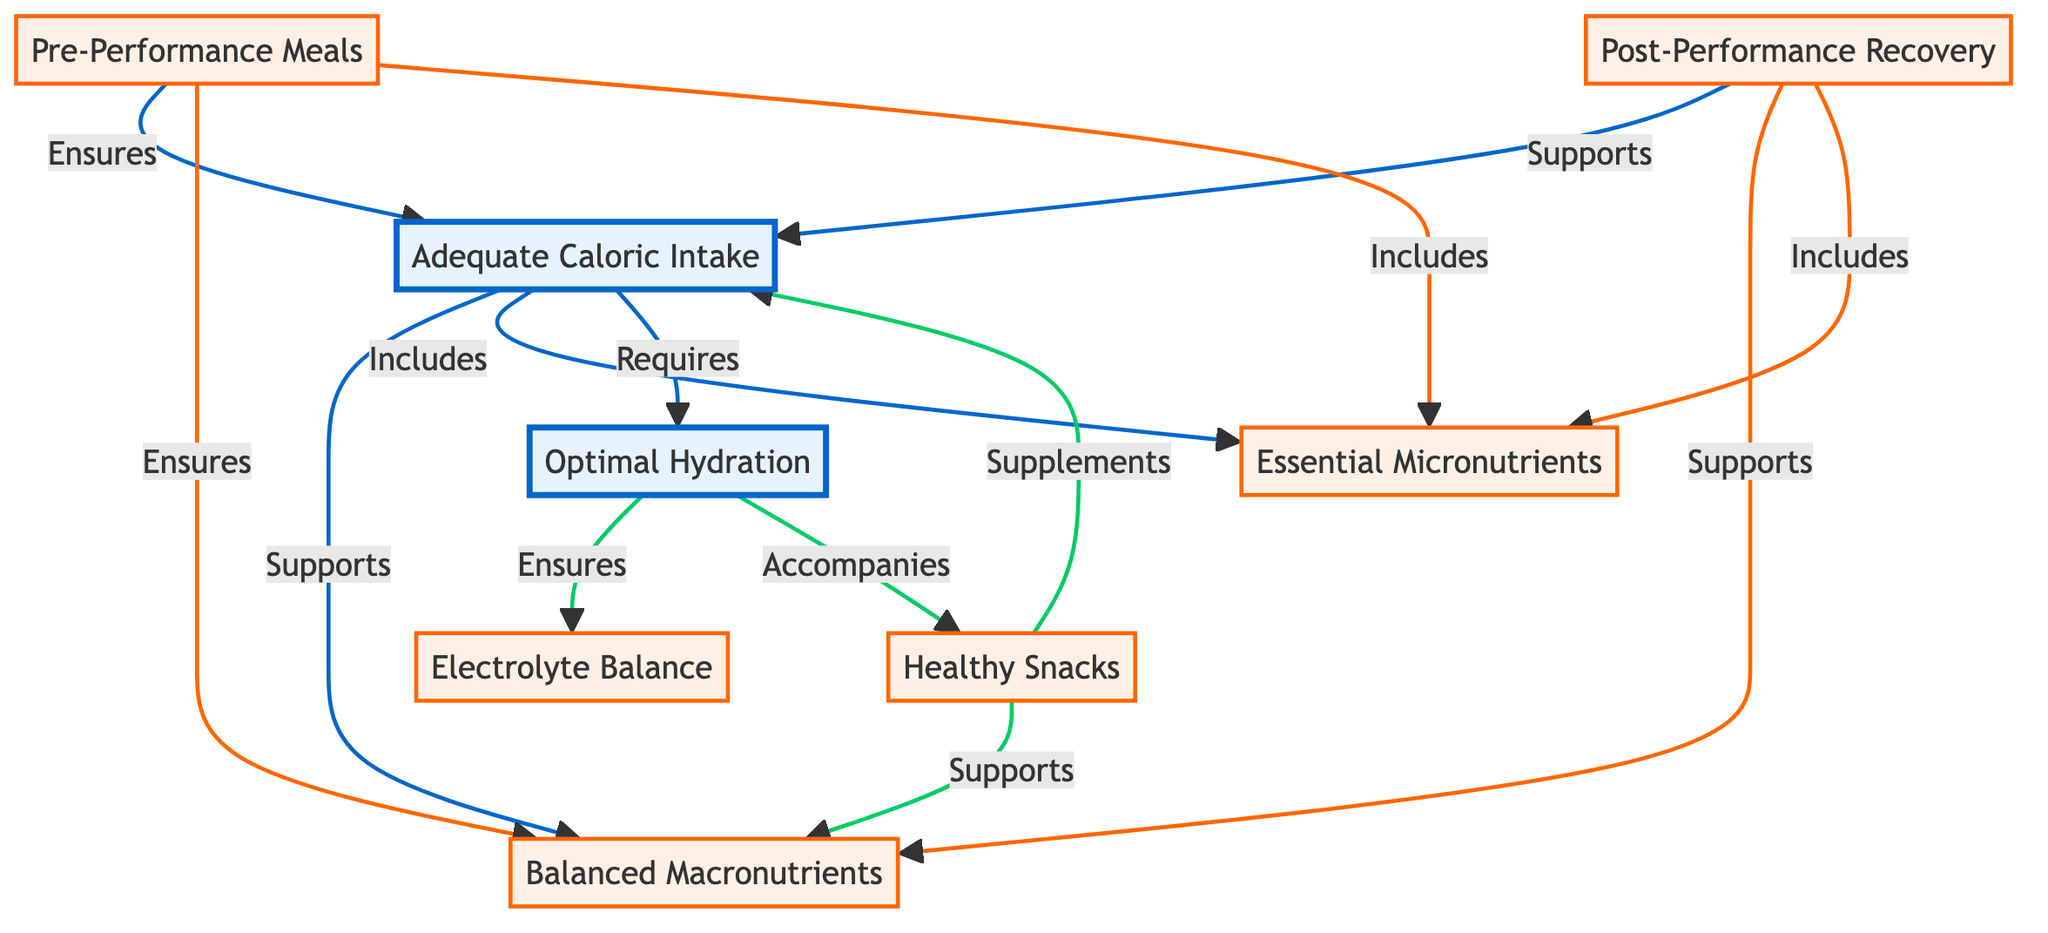What are the main nodes in the diagram? The main nodes are identified as those with significant roles in the overall context of the diagram. In this case, the two main nodes present are "Adequate Caloric Intake" and "Optimal Hydration."
Answer: Adequate Caloric Intake, Optimal Hydration How many sub-nodes are there? The diagram shows four sub-nodes that provide details or additional information related to the main nodes. Those are "Balanced Macronutrients," "Essential Micronutrients," "Pre-Performance Meals," and "Post-Performance Recovery," along with "Electrolyte Balance" and "Healthy Snacks," making a total of six sub-nodes.
Answer: 6 What relationship supports "Macronutrient Balance"? The diagram indicates that "Adequate Caloric Intake" and "Pre-Performance Meals" both support "Macronutrient Balance." This can be inferred by examining the arrows leading to the "Macronutrient Balance" sub-node.
Answer: Adequate Caloric Intake, Pre-Performance Meals Which node requires hydration? By examining the arrows pointing to "Hydration," it is clear that "Adequate Caloric Intake" requires hydration. This highlights the connection between maintaining caloric requirements and staying hydrated for optimal performance.
Answer: Adequate Caloric Intake What does "Hydration" ensure according to the diagram? The diagram explicitly states that "Hydration" ensures "Electrolyte Balance." This relationship is shown through a directed arrow indicating that optimal hydration is essential for maintaining the balance of electrolytes in the body.
Answer: Electrolyte Balance How do "Snacks" support "Macronutrient Balance"? The connection between "Snacks" and "Macronutrient Balance" can be inferred. "Snacks" supplements adequate caloric intake and thereby supports the overall balance of macronutrients necessary for dance performance.
Answer: Supports Adequate Caloric Intake What is included in "Pre-Performance Meals"? The diagram outlines that "Pre-Performance Meals" includes "Micronutrients." This indicates that proper meal planning before dance performances incorporates essential vitamins and minerals that dancers need.
Answer: Micronutrients 